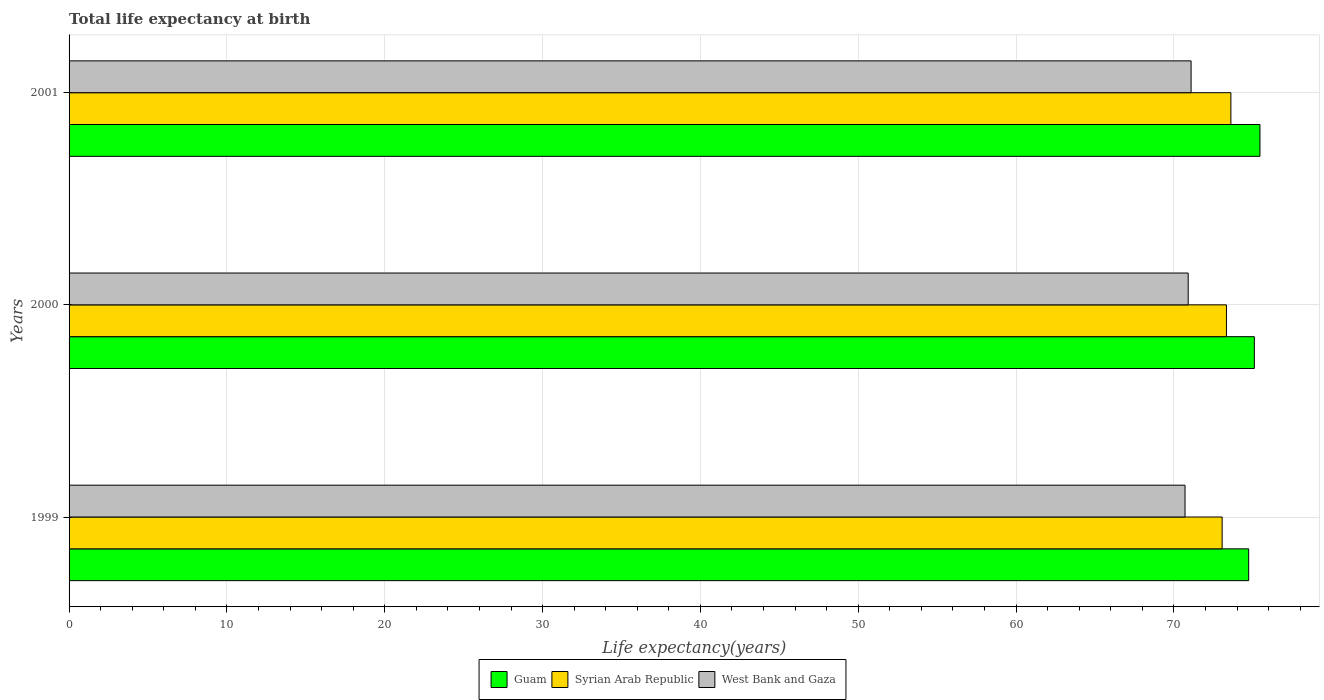How many different coloured bars are there?
Your response must be concise. 3. Are the number of bars per tick equal to the number of legend labels?
Your answer should be compact. Yes. Are the number of bars on each tick of the Y-axis equal?
Give a very brief answer. Yes. How many bars are there on the 3rd tick from the bottom?
Ensure brevity in your answer.  3. What is the label of the 3rd group of bars from the top?
Provide a short and direct response. 1999. What is the life expectancy at birth in in Syrian Arab Republic in 1999?
Offer a terse response. 73.06. Across all years, what is the maximum life expectancy at birth in in West Bank and Gaza?
Offer a very short reply. 71.09. Across all years, what is the minimum life expectancy at birth in in West Bank and Gaza?
Provide a short and direct response. 70.71. In which year was the life expectancy at birth in in Syrian Arab Republic maximum?
Your response must be concise. 2001. What is the total life expectancy at birth in in Guam in the graph?
Offer a terse response. 225.29. What is the difference between the life expectancy at birth in in Guam in 1999 and that in 2000?
Offer a very short reply. -0.36. What is the difference between the life expectancy at birth in in West Bank and Gaza in 2000 and the life expectancy at birth in in Syrian Arab Republic in 2001?
Provide a short and direct response. -2.7. What is the average life expectancy at birth in in West Bank and Gaza per year?
Your response must be concise. 70.9. In the year 2000, what is the difference between the life expectancy at birth in in Syrian Arab Republic and life expectancy at birth in in West Bank and Gaza?
Ensure brevity in your answer.  2.42. In how many years, is the life expectancy at birth in in Syrian Arab Republic greater than 58 years?
Your answer should be very brief. 3. What is the ratio of the life expectancy at birth in in Guam in 1999 to that in 2000?
Your answer should be very brief. 1. What is the difference between the highest and the second highest life expectancy at birth in in Guam?
Provide a short and direct response. 0.35. What is the difference between the highest and the lowest life expectancy at birth in in Guam?
Your answer should be compact. 0.71. In how many years, is the life expectancy at birth in in Guam greater than the average life expectancy at birth in in Guam taken over all years?
Your answer should be very brief. 2. Is the sum of the life expectancy at birth in in Guam in 2000 and 2001 greater than the maximum life expectancy at birth in in West Bank and Gaza across all years?
Give a very brief answer. Yes. What does the 2nd bar from the top in 2001 represents?
Make the answer very short. Syrian Arab Republic. What does the 2nd bar from the bottom in 1999 represents?
Make the answer very short. Syrian Arab Republic. Are all the bars in the graph horizontal?
Your response must be concise. Yes. How many years are there in the graph?
Your response must be concise. 3. What is the difference between two consecutive major ticks on the X-axis?
Offer a very short reply. 10. Are the values on the major ticks of X-axis written in scientific E-notation?
Your answer should be compact. No. Does the graph contain any zero values?
Give a very brief answer. No. Does the graph contain grids?
Keep it short and to the point. Yes. What is the title of the graph?
Provide a short and direct response. Total life expectancy at birth. What is the label or title of the X-axis?
Give a very brief answer. Life expectancy(years). What is the label or title of the Y-axis?
Provide a succinct answer. Years. What is the Life expectancy(years) in Guam in 1999?
Keep it short and to the point. 74.74. What is the Life expectancy(years) in Syrian Arab Republic in 1999?
Your answer should be compact. 73.06. What is the Life expectancy(years) of West Bank and Gaza in 1999?
Provide a succinct answer. 70.71. What is the Life expectancy(years) of Guam in 2000?
Offer a very short reply. 75.1. What is the Life expectancy(years) of Syrian Arab Republic in 2000?
Keep it short and to the point. 73.33. What is the Life expectancy(years) in West Bank and Gaza in 2000?
Keep it short and to the point. 70.91. What is the Life expectancy(years) in Guam in 2001?
Provide a short and direct response. 75.45. What is the Life expectancy(years) of Syrian Arab Republic in 2001?
Offer a terse response. 73.61. What is the Life expectancy(years) in West Bank and Gaza in 2001?
Your answer should be compact. 71.09. Across all years, what is the maximum Life expectancy(years) of Guam?
Give a very brief answer. 75.45. Across all years, what is the maximum Life expectancy(years) of Syrian Arab Republic?
Provide a short and direct response. 73.61. Across all years, what is the maximum Life expectancy(years) of West Bank and Gaza?
Offer a terse response. 71.09. Across all years, what is the minimum Life expectancy(years) in Guam?
Ensure brevity in your answer.  74.74. Across all years, what is the minimum Life expectancy(years) of Syrian Arab Republic?
Offer a terse response. 73.06. Across all years, what is the minimum Life expectancy(years) in West Bank and Gaza?
Offer a very short reply. 70.71. What is the total Life expectancy(years) in Guam in the graph?
Your answer should be very brief. 225.29. What is the total Life expectancy(years) in Syrian Arab Republic in the graph?
Provide a succinct answer. 220. What is the total Life expectancy(years) of West Bank and Gaza in the graph?
Your response must be concise. 212.7. What is the difference between the Life expectancy(years) in Guam in 1999 and that in 2000?
Offer a very short reply. -0.36. What is the difference between the Life expectancy(years) of Syrian Arab Republic in 1999 and that in 2000?
Give a very brief answer. -0.27. What is the difference between the Life expectancy(years) of West Bank and Gaza in 1999 and that in 2000?
Offer a terse response. -0.2. What is the difference between the Life expectancy(years) of Guam in 1999 and that in 2001?
Your answer should be compact. -0.71. What is the difference between the Life expectancy(years) of Syrian Arab Republic in 1999 and that in 2001?
Your answer should be compact. -0.55. What is the difference between the Life expectancy(years) of West Bank and Gaza in 1999 and that in 2001?
Give a very brief answer. -0.38. What is the difference between the Life expectancy(years) in Guam in 2000 and that in 2001?
Keep it short and to the point. -0.35. What is the difference between the Life expectancy(years) in Syrian Arab Republic in 2000 and that in 2001?
Your response must be concise. -0.28. What is the difference between the Life expectancy(years) of West Bank and Gaza in 2000 and that in 2001?
Ensure brevity in your answer.  -0.18. What is the difference between the Life expectancy(years) in Guam in 1999 and the Life expectancy(years) in Syrian Arab Republic in 2000?
Your response must be concise. 1.41. What is the difference between the Life expectancy(years) in Guam in 1999 and the Life expectancy(years) in West Bank and Gaza in 2000?
Keep it short and to the point. 3.83. What is the difference between the Life expectancy(years) in Syrian Arab Republic in 1999 and the Life expectancy(years) in West Bank and Gaza in 2000?
Offer a terse response. 2.15. What is the difference between the Life expectancy(years) in Guam in 1999 and the Life expectancy(years) in Syrian Arab Republic in 2001?
Give a very brief answer. 1.13. What is the difference between the Life expectancy(years) of Guam in 1999 and the Life expectancy(years) of West Bank and Gaza in 2001?
Offer a terse response. 3.65. What is the difference between the Life expectancy(years) of Syrian Arab Republic in 1999 and the Life expectancy(years) of West Bank and Gaza in 2001?
Keep it short and to the point. 1.97. What is the difference between the Life expectancy(years) in Guam in 2000 and the Life expectancy(years) in Syrian Arab Republic in 2001?
Keep it short and to the point. 1.49. What is the difference between the Life expectancy(years) of Guam in 2000 and the Life expectancy(years) of West Bank and Gaza in 2001?
Your response must be concise. 4.01. What is the difference between the Life expectancy(years) of Syrian Arab Republic in 2000 and the Life expectancy(years) of West Bank and Gaza in 2001?
Give a very brief answer. 2.24. What is the average Life expectancy(years) of Guam per year?
Your response must be concise. 75.1. What is the average Life expectancy(years) in Syrian Arab Republic per year?
Give a very brief answer. 73.33. What is the average Life expectancy(years) in West Bank and Gaza per year?
Offer a terse response. 70.9. In the year 1999, what is the difference between the Life expectancy(years) in Guam and Life expectancy(years) in Syrian Arab Republic?
Your answer should be very brief. 1.68. In the year 1999, what is the difference between the Life expectancy(years) in Guam and Life expectancy(years) in West Bank and Gaza?
Offer a terse response. 4.03. In the year 1999, what is the difference between the Life expectancy(years) of Syrian Arab Republic and Life expectancy(years) of West Bank and Gaza?
Provide a short and direct response. 2.35. In the year 2000, what is the difference between the Life expectancy(years) in Guam and Life expectancy(years) in Syrian Arab Republic?
Make the answer very short. 1.77. In the year 2000, what is the difference between the Life expectancy(years) of Guam and Life expectancy(years) of West Bank and Gaza?
Provide a short and direct response. 4.19. In the year 2000, what is the difference between the Life expectancy(years) of Syrian Arab Republic and Life expectancy(years) of West Bank and Gaza?
Make the answer very short. 2.42. In the year 2001, what is the difference between the Life expectancy(years) of Guam and Life expectancy(years) of Syrian Arab Republic?
Offer a terse response. 1.84. In the year 2001, what is the difference between the Life expectancy(years) in Guam and Life expectancy(years) in West Bank and Gaza?
Provide a succinct answer. 4.36. In the year 2001, what is the difference between the Life expectancy(years) in Syrian Arab Republic and Life expectancy(years) in West Bank and Gaza?
Offer a terse response. 2.52. What is the ratio of the Life expectancy(years) of Guam in 1999 to that in 2000?
Keep it short and to the point. 1. What is the ratio of the Life expectancy(years) of West Bank and Gaza in 1999 to that in 2000?
Provide a short and direct response. 1. What is the ratio of the Life expectancy(years) in Guam in 1999 to that in 2001?
Your response must be concise. 0.99. What is the ratio of the Life expectancy(years) in Syrian Arab Republic in 1999 to that in 2001?
Provide a succinct answer. 0.99. What is the ratio of the Life expectancy(years) of Syrian Arab Republic in 2000 to that in 2001?
Provide a short and direct response. 1. What is the difference between the highest and the second highest Life expectancy(years) of Guam?
Your response must be concise. 0.35. What is the difference between the highest and the second highest Life expectancy(years) of Syrian Arab Republic?
Give a very brief answer. 0.28. What is the difference between the highest and the second highest Life expectancy(years) in West Bank and Gaza?
Give a very brief answer. 0.18. What is the difference between the highest and the lowest Life expectancy(years) in Guam?
Make the answer very short. 0.71. What is the difference between the highest and the lowest Life expectancy(years) in Syrian Arab Republic?
Give a very brief answer. 0.55. What is the difference between the highest and the lowest Life expectancy(years) in West Bank and Gaza?
Provide a short and direct response. 0.38. 